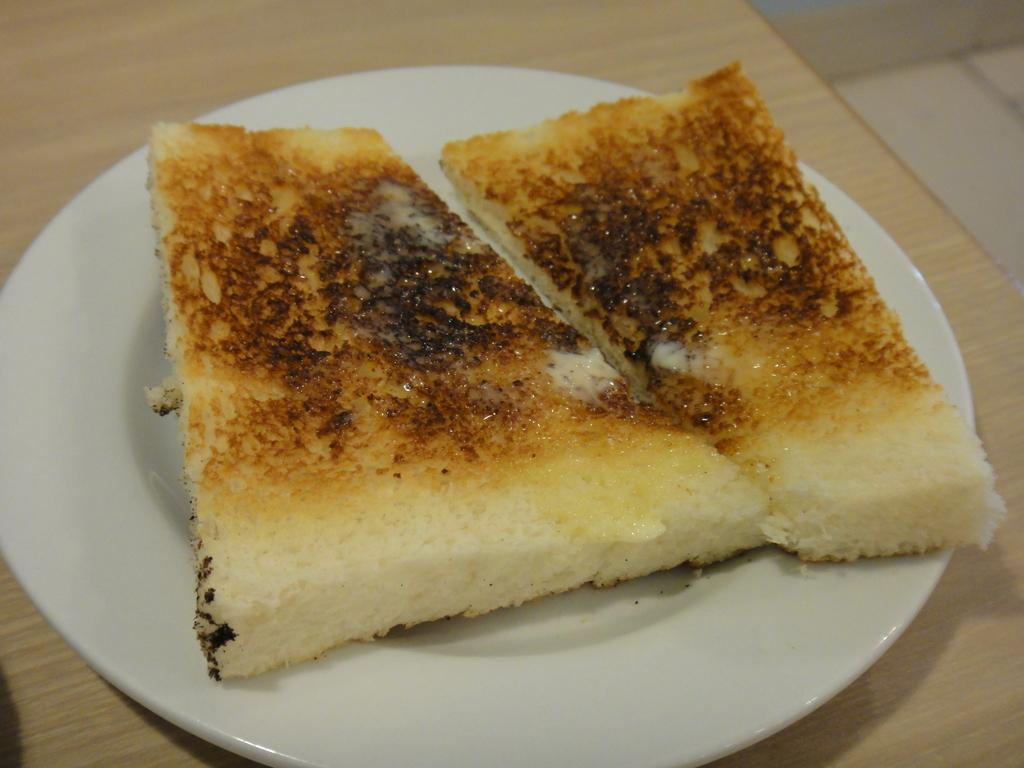What type of food is visible in the image? There is a roasted bread in the image. How is the roasted bread presented in the image? The roasted bread is on a white plate. What is the surface on which the white plate is placed? The white plate is placed on a wooden table top. What type of stone can be seen on the street in the image? There is no street or stone present in the image; it features a roasted bread on a white plate placed on a wooden table top. 